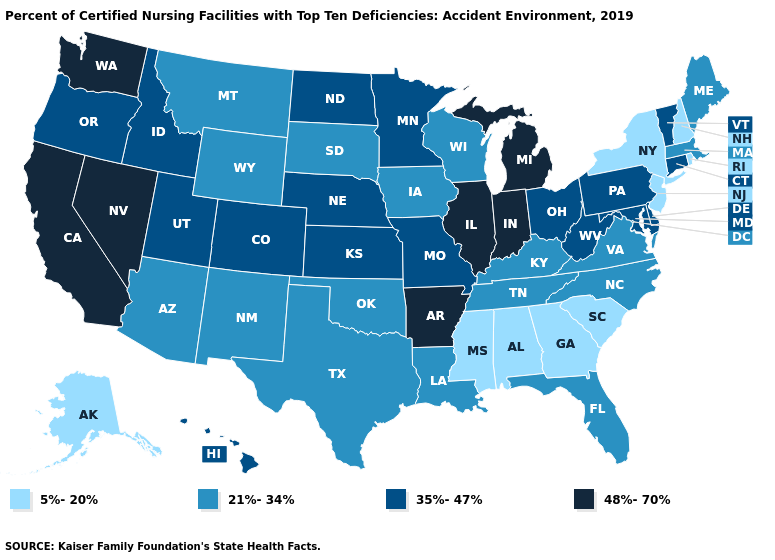Name the states that have a value in the range 48%-70%?
Write a very short answer. Arkansas, California, Illinois, Indiana, Michigan, Nevada, Washington. Does the first symbol in the legend represent the smallest category?
Write a very short answer. Yes. What is the highest value in the West ?
Give a very brief answer. 48%-70%. Does New Mexico have the highest value in the West?
Short answer required. No. Among the states that border Kansas , which have the highest value?
Be succinct. Colorado, Missouri, Nebraska. What is the value of Oregon?
Keep it brief. 35%-47%. Among the states that border Kansas , does Missouri have the lowest value?
Be succinct. No. What is the value of Illinois?
Be succinct. 48%-70%. Does New Hampshire have the same value as Maine?
Write a very short answer. No. What is the value of Georgia?
Answer briefly. 5%-20%. Does Michigan have the same value as Hawaii?
Short answer required. No. What is the value of Colorado?
Short answer required. 35%-47%. Name the states that have a value in the range 5%-20%?
Concise answer only. Alabama, Alaska, Georgia, Mississippi, New Hampshire, New Jersey, New York, Rhode Island, South Carolina. Name the states that have a value in the range 21%-34%?
Write a very short answer. Arizona, Florida, Iowa, Kentucky, Louisiana, Maine, Massachusetts, Montana, New Mexico, North Carolina, Oklahoma, South Dakota, Tennessee, Texas, Virginia, Wisconsin, Wyoming. What is the highest value in the USA?
Quick response, please. 48%-70%. 